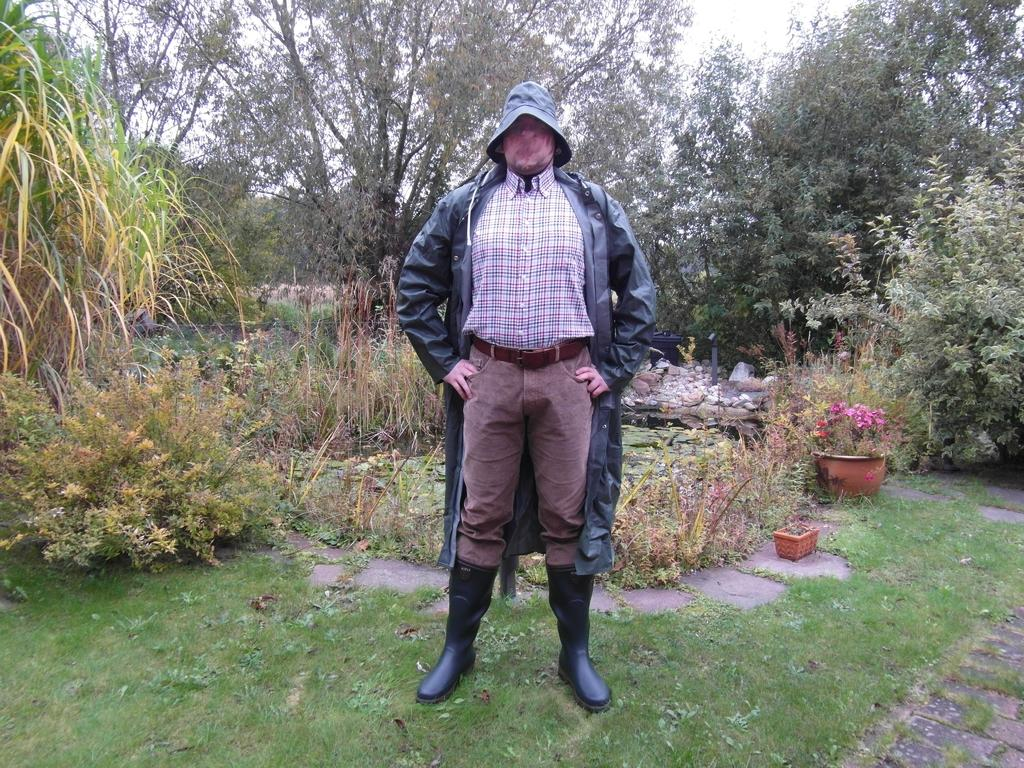Who is present in the image? There is a man in the image. What is the man wearing? The man is wearing a black jacket. Where is the man standing? The man is standing on the grass. What can be seen in the background of the image? There are plants, pots, trees, and the sky visible in the background of the image. What type of advertisement can be seen on the man's jacket in the image? There is no advertisement visible on the man's jacket in the image. Can you tell me how many stars are present in the image? There are no stars visible in the image; it features a man standing on grass with a black jacket and a background of plants, pots, trees, and the sky. 